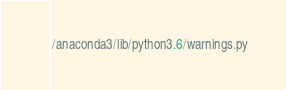<code> <loc_0><loc_0><loc_500><loc_500><_Python_>/anaconda3/lib/python3.6/warnings.py</code> 